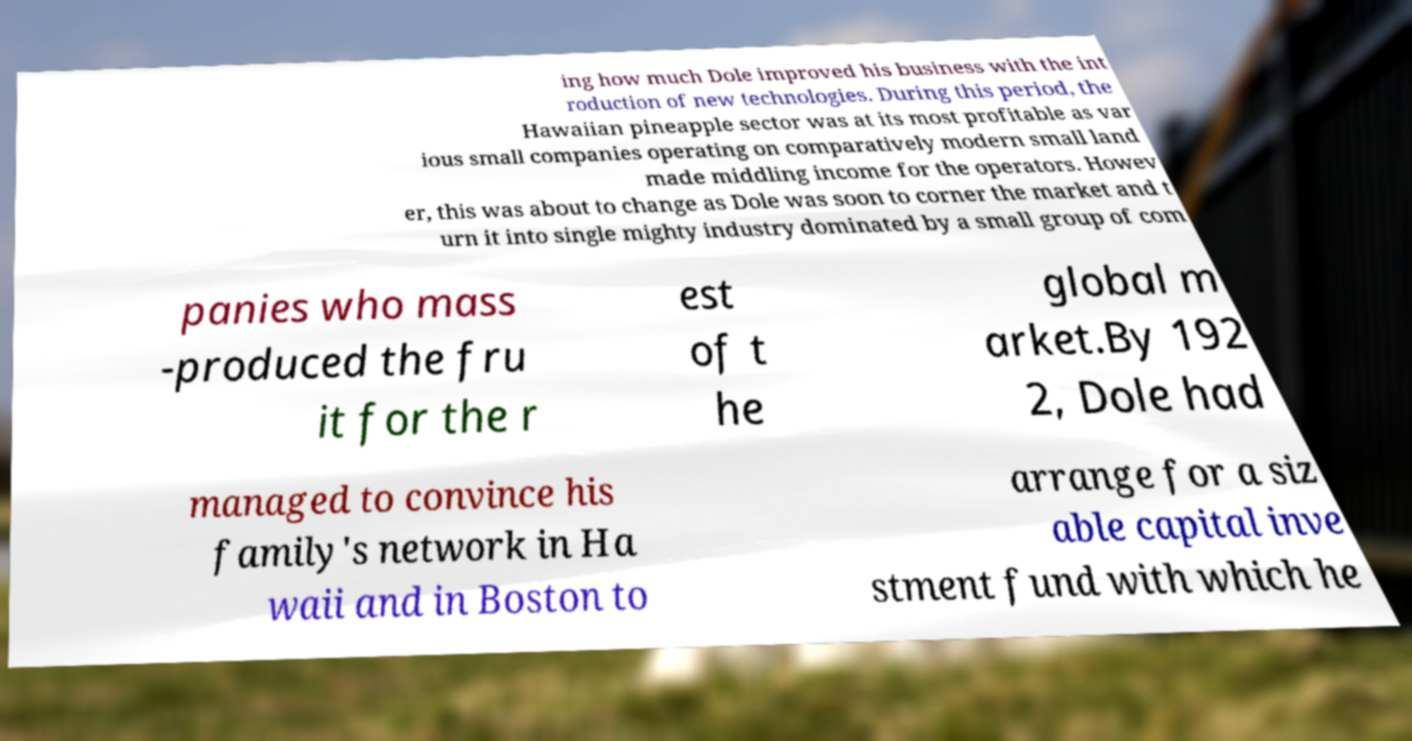Please identify and transcribe the text found in this image. ing how much Dole improved his business with the int roduction of new technologies. During this period, the Hawaiian pineapple sector was at its most profitable as var ious small companies operating on comparatively modern small land made middling income for the operators. Howev er, this was about to change as Dole was soon to corner the market and t urn it into single mighty industry dominated by a small group of com panies who mass -produced the fru it for the r est of t he global m arket.By 192 2, Dole had managed to convince his family's network in Ha waii and in Boston to arrange for a siz able capital inve stment fund with which he 